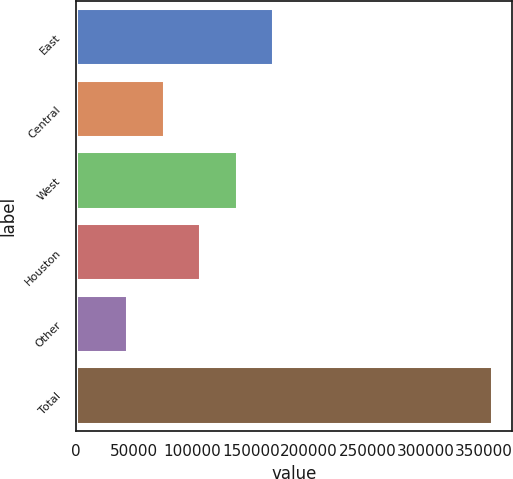Convert chart. <chart><loc_0><loc_0><loc_500><loc_500><bar_chart><fcel>East<fcel>Central<fcel>West<fcel>Houston<fcel>Other<fcel>Total<nl><fcel>169019<fcel>75284.7<fcel>137774<fcel>106529<fcel>44040<fcel>356487<nl></chart> 